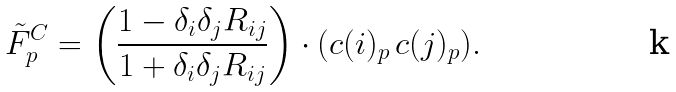Convert formula to latex. <formula><loc_0><loc_0><loc_500><loc_500>\tilde { F } ^ { C } _ { p } = \left ( \frac { 1 - \delta _ { i } \delta _ { j } R _ { i j } } { 1 + \delta _ { i } \delta _ { j } R _ { i j } } \right ) \cdot ( c ( i ) _ { p } \, c ( j ) _ { p } ) .</formula> 